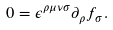<formula> <loc_0><loc_0><loc_500><loc_500>0 = \epsilon ^ { \rho \mu \nu \sigma } \partial _ { \rho } f _ { \sigma } .</formula> 